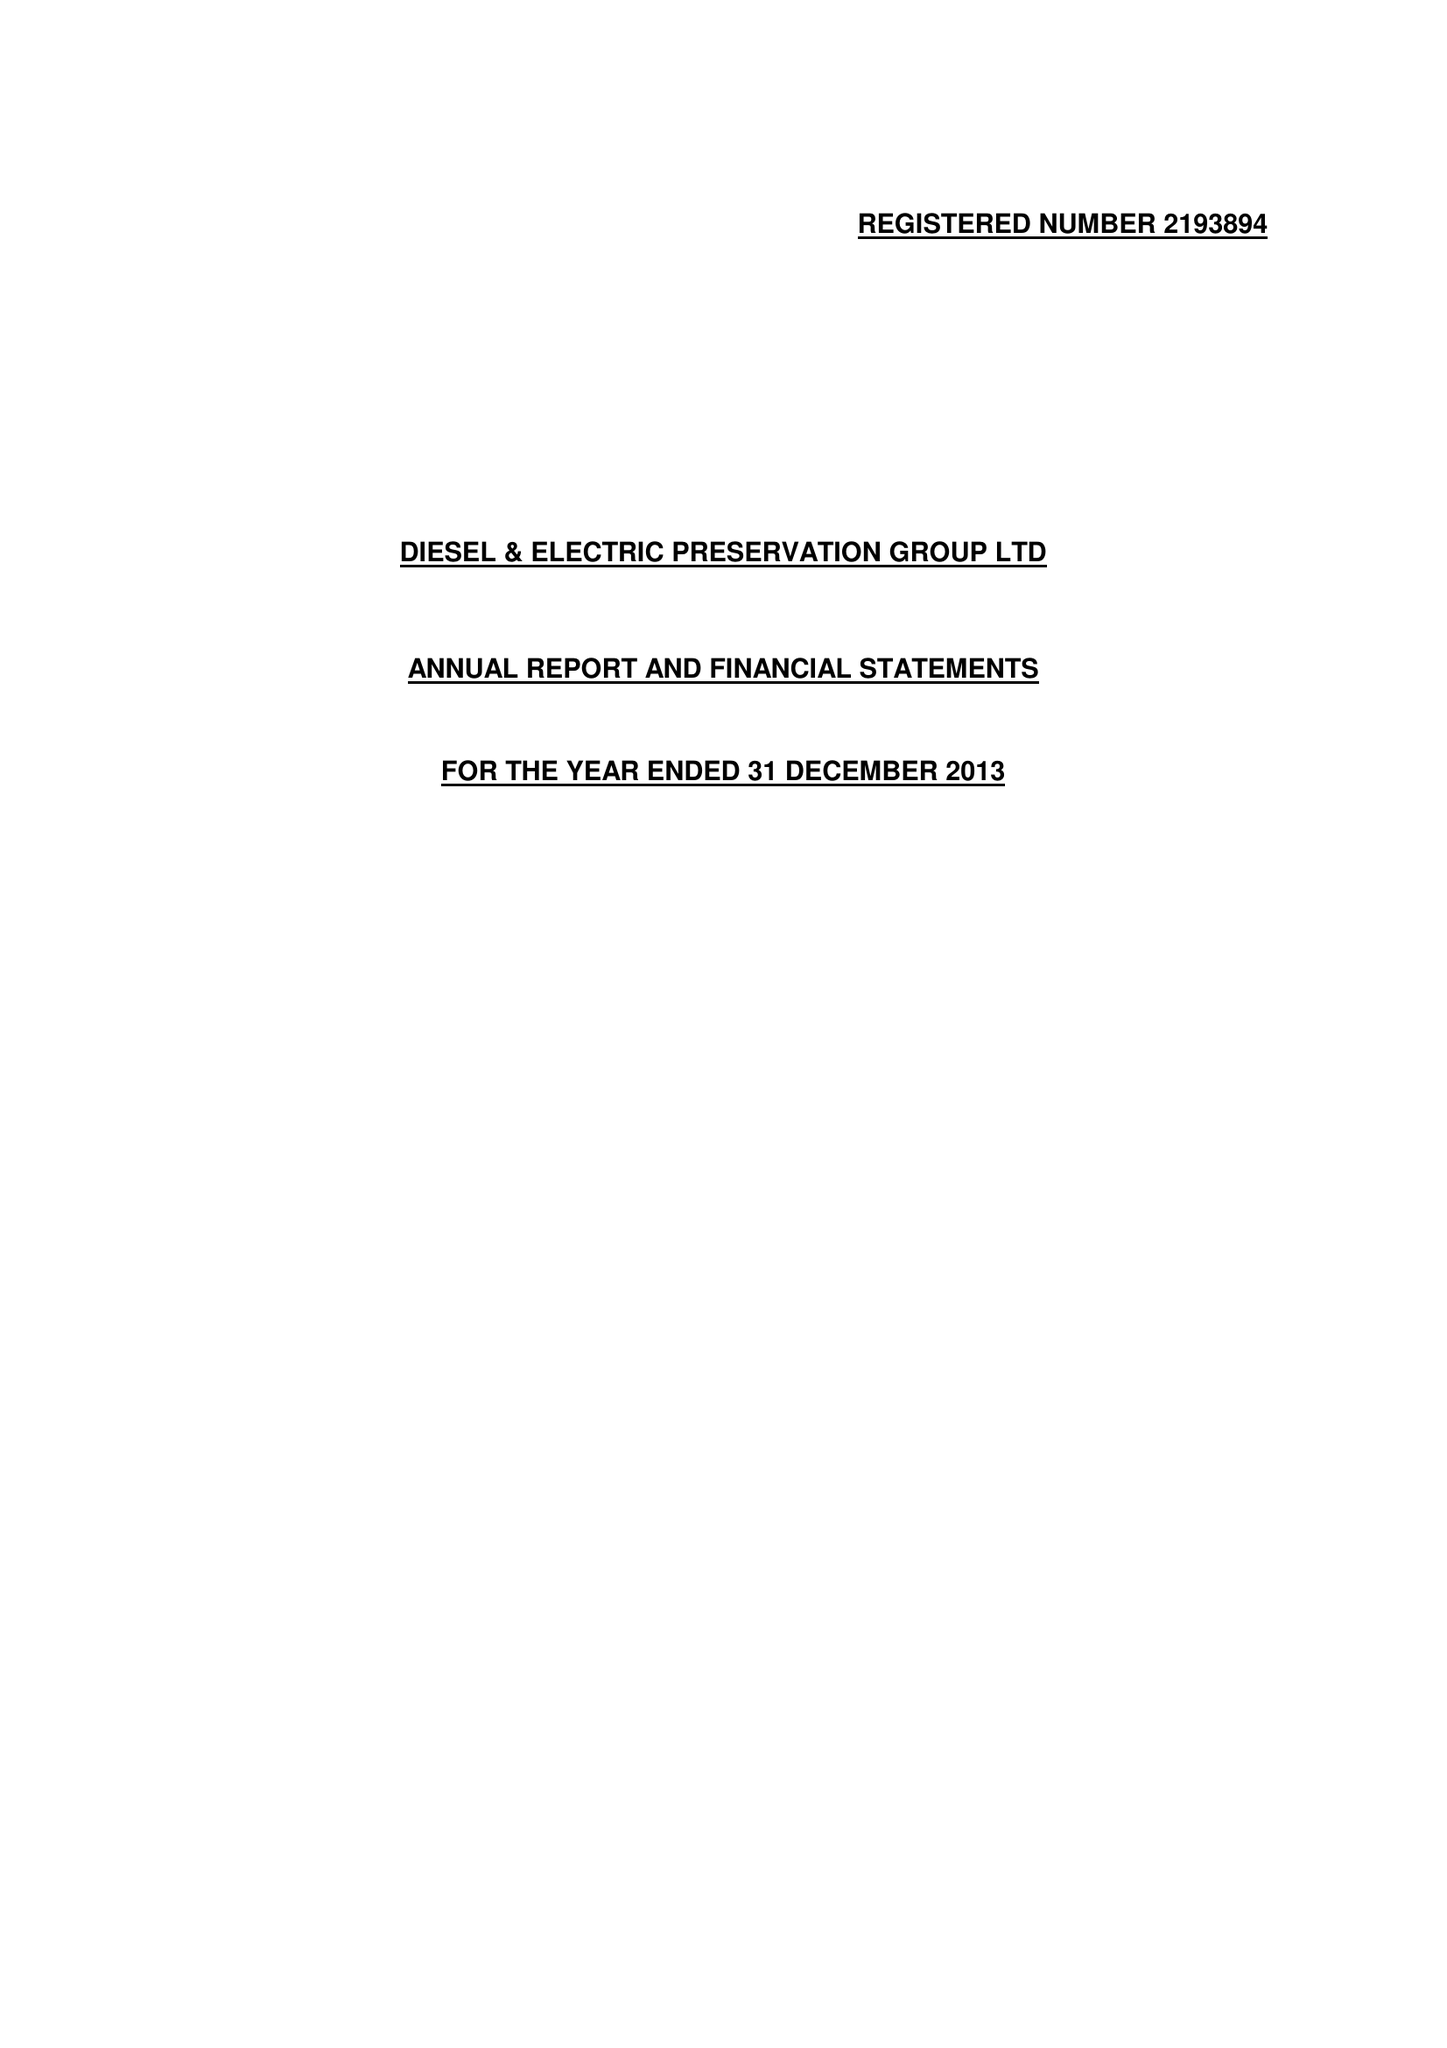What is the value for the address__post_town?
Answer the question using a single word or phrase. TAUNTON 